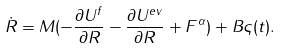Convert formula to latex. <formula><loc_0><loc_0><loc_500><loc_500>\dot { R } = { M } ( - \frac { \partial U ^ { f } } { \partial { R } } - \frac { \partial U ^ { e v } } { \partial { R } } + { F } ^ { \alpha } ) + { B } \varsigma ( t ) .</formula> 